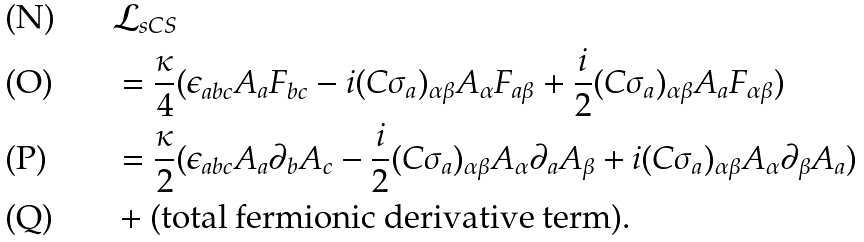<formula> <loc_0><loc_0><loc_500><loc_500>& \mathcal { L } _ { s C S } \\ & = \frac { \kappa } { 4 } ( \epsilon _ { a b c } A _ { a } F _ { b c } - i ( C \sigma _ { a } ) _ { \alpha \beta } A _ { \alpha } F _ { a \beta } + \frac { i } { 2 } ( C \sigma _ { a } ) _ { \alpha \beta } A _ { a } F _ { \alpha \beta } ) \\ & = \frac { \kappa } { 2 } ( \epsilon _ { a b c } A _ { a } \partial _ { b } A _ { c } - \frac { i } { 2 } ( C \sigma _ { a } ) _ { \alpha \beta } A _ { \alpha } \partial _ { a } A _ { \beta } + i ( C \sigma _ { a } ) _ { \alpha \beta } A _ { \alpha } \partial _ { \beta } A _ { a } ) \\ & + ( \text {total fermionic derivative term} ) .</formula> 